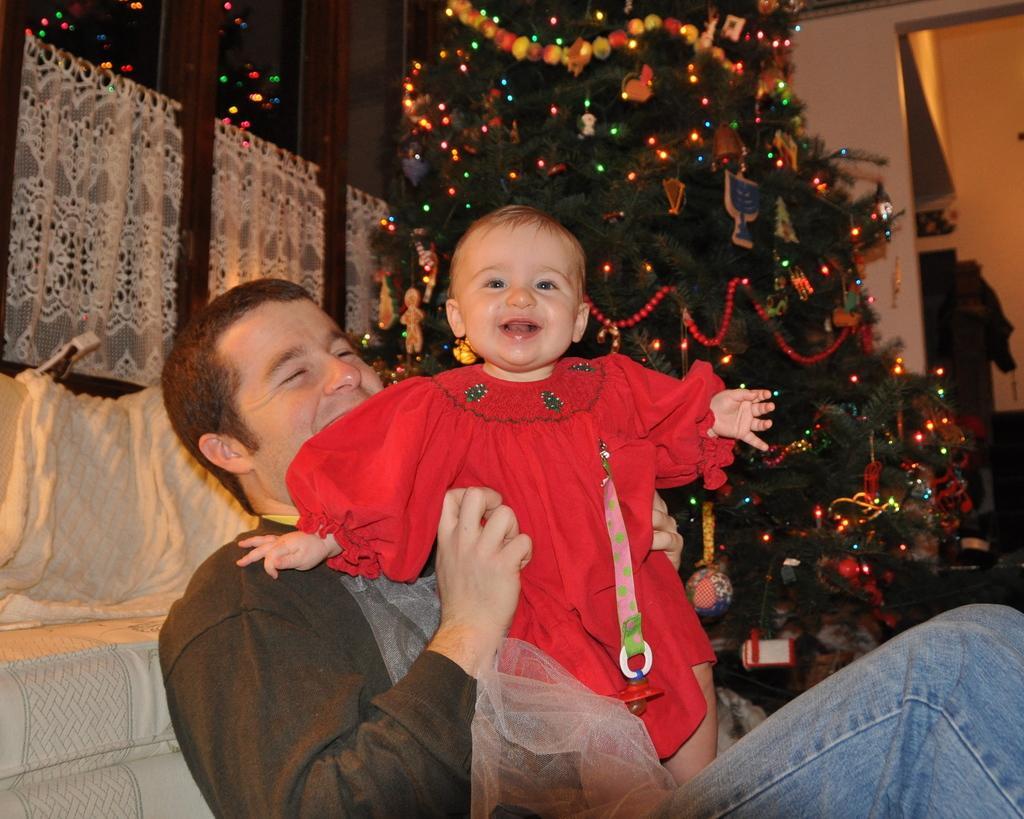Could you give a brief overview of what you see in this image? In this picture I can see a man sitting and holding a baby and I can see a tree in the back with few lights, color papers and few decorative balls and I can see a glass window on the left side and it looks like a pillow on the left side. 